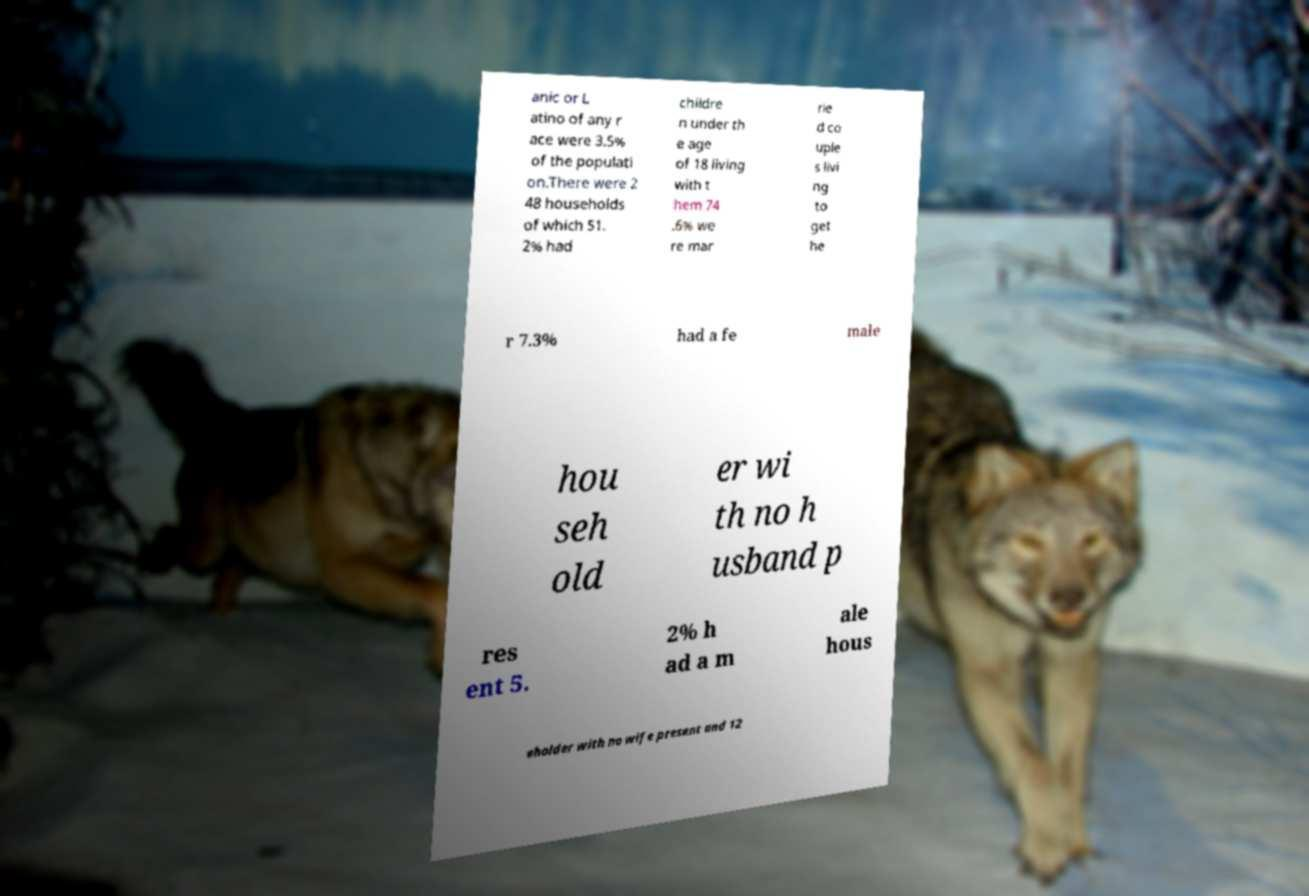For documentation purposes, I need the text within this image transcribed. Could you provide that? anic or L atino of any r ace were 3.5% of the populati on.There were 2 48 households of which 51. 2% had childre n under th e age of 18 living with t hem 74 .6% we re mar rie d co uple s livi ng to get he r 7.3% had a fe male hou seh old er wi th no h usband p res ent 5. 2% h ad a m ale hous eholder with no wife present and 12 